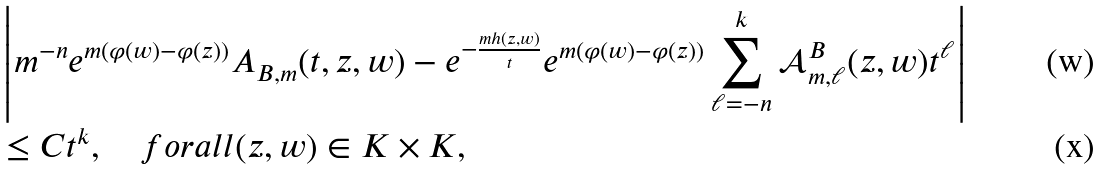<formula> <loc_0><loc_0><loc_500><loc_500>& \left | m ^ { - n } e ^ { m ( \varphi ( w ) - \varphi ( z ) ) } A _ { B , m } ( t , z , w ) - e ^ { - \frac { m h ( z , w ) } { t } } e ^ { m ( \varphi ( w ) - \varphi ( z ) ) } \sum _ { \ell = - n } ^ { k } \mathcal { A } ^ { B } _ { m , \ell } ( z , w ) t ^ { \ell } \right | \\ & \leq C t ^ { k } , \quad f o r a l l ( z , w ) \in K \times K ,</formula> 